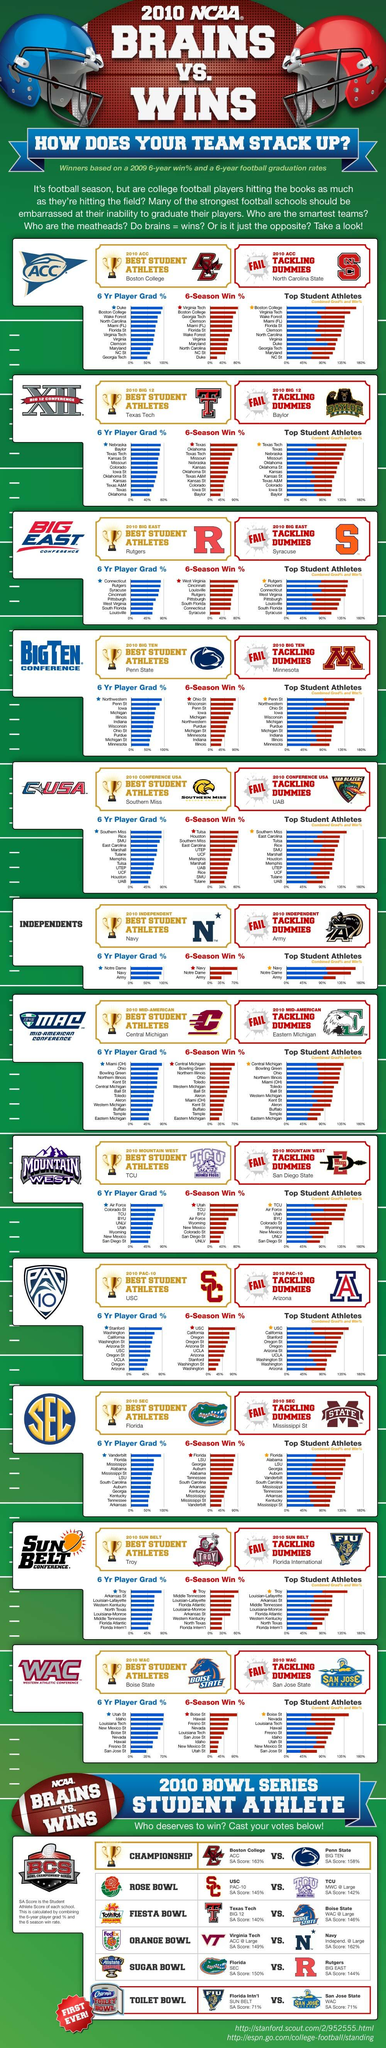Highlight a few significant elements in this photo. In 2010, Duke University, which is part of the Atlantic Coast Conference (ACC), had a win percentage of less than 40%. In 2010, Texas had the highest win percentage among the Big 12 colleges. Syracuse University was awarded the 2010 Big East Tackling Dummies trophy. Boston College has a higher SA score than Penn State. Texas Tech, a top performer among the Big 12 colleges, ranked in the top three in all categories including graduation rate, win percentage, and having the top student athletes. 